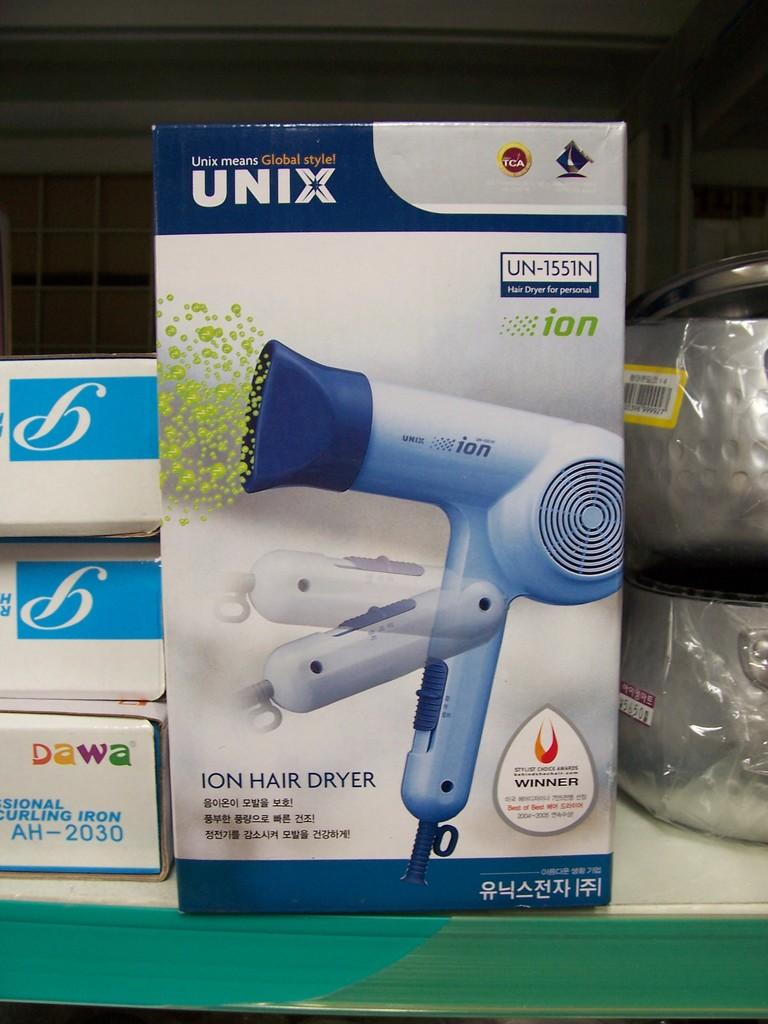What is located in the center of the image? There are boxes in the center of the image. What objects can be seen on the table in the image? Vessels are present on the table. What can be seen in the background of the image? There is a wall in the background of the image. What is visible at the top of the image? There is a roof visible at the top of the image. How many eyes can be seen on the boxes in the image? There are no eyes present on the boxes in the image. What type of twist can be observed in the vessels on the table? There is no twist present in the vessels on the table; they are stationary objects. 